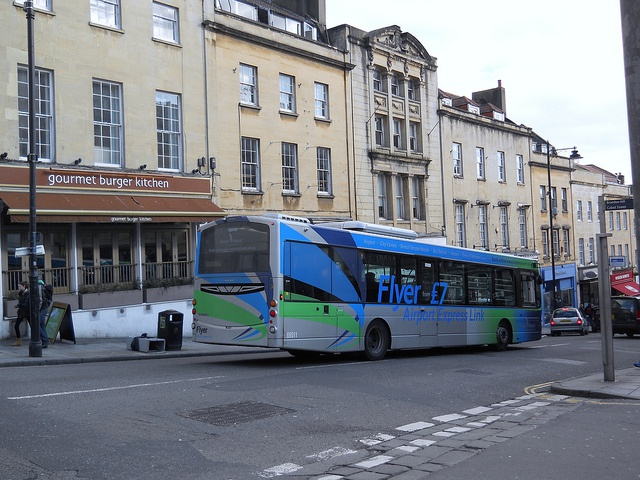Describe the objects in this image and their specific colors. I can see bus in darkgray, black, gray, blue, and teal tones, people in darkgray, black, gray, navy, and teal tones, car in darkgray, black, navy, gray, and darkblue tones, car in darkgray, black, gray, and navy tones, and people in darkgray, black, navy, and blue tones in this image. 